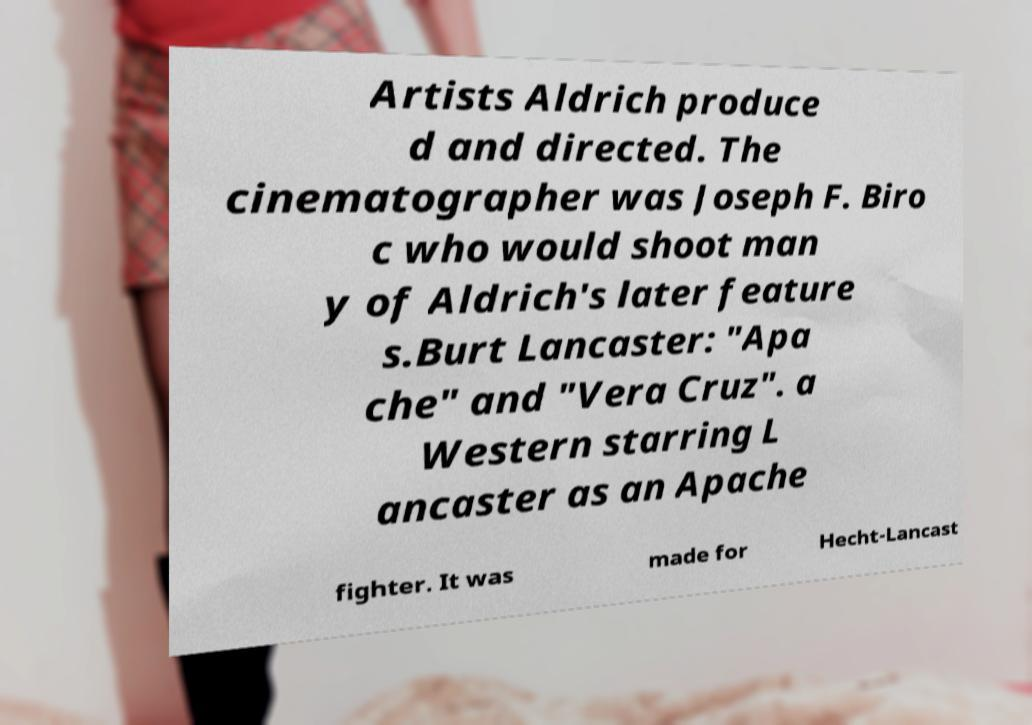There's text embedded in this image that I need extracted. Can you transcribe it verbatim? Artists Aldrich produce d and directed. The cinematographer was Joseph F. Biro c who would shoot man y of Aldrich's later feature s.Burt Lancaster: "Apa che" and "Vera Cruz". a Western starring L ancaster as an Apache fighter. It was made for Hecht-Lancast 